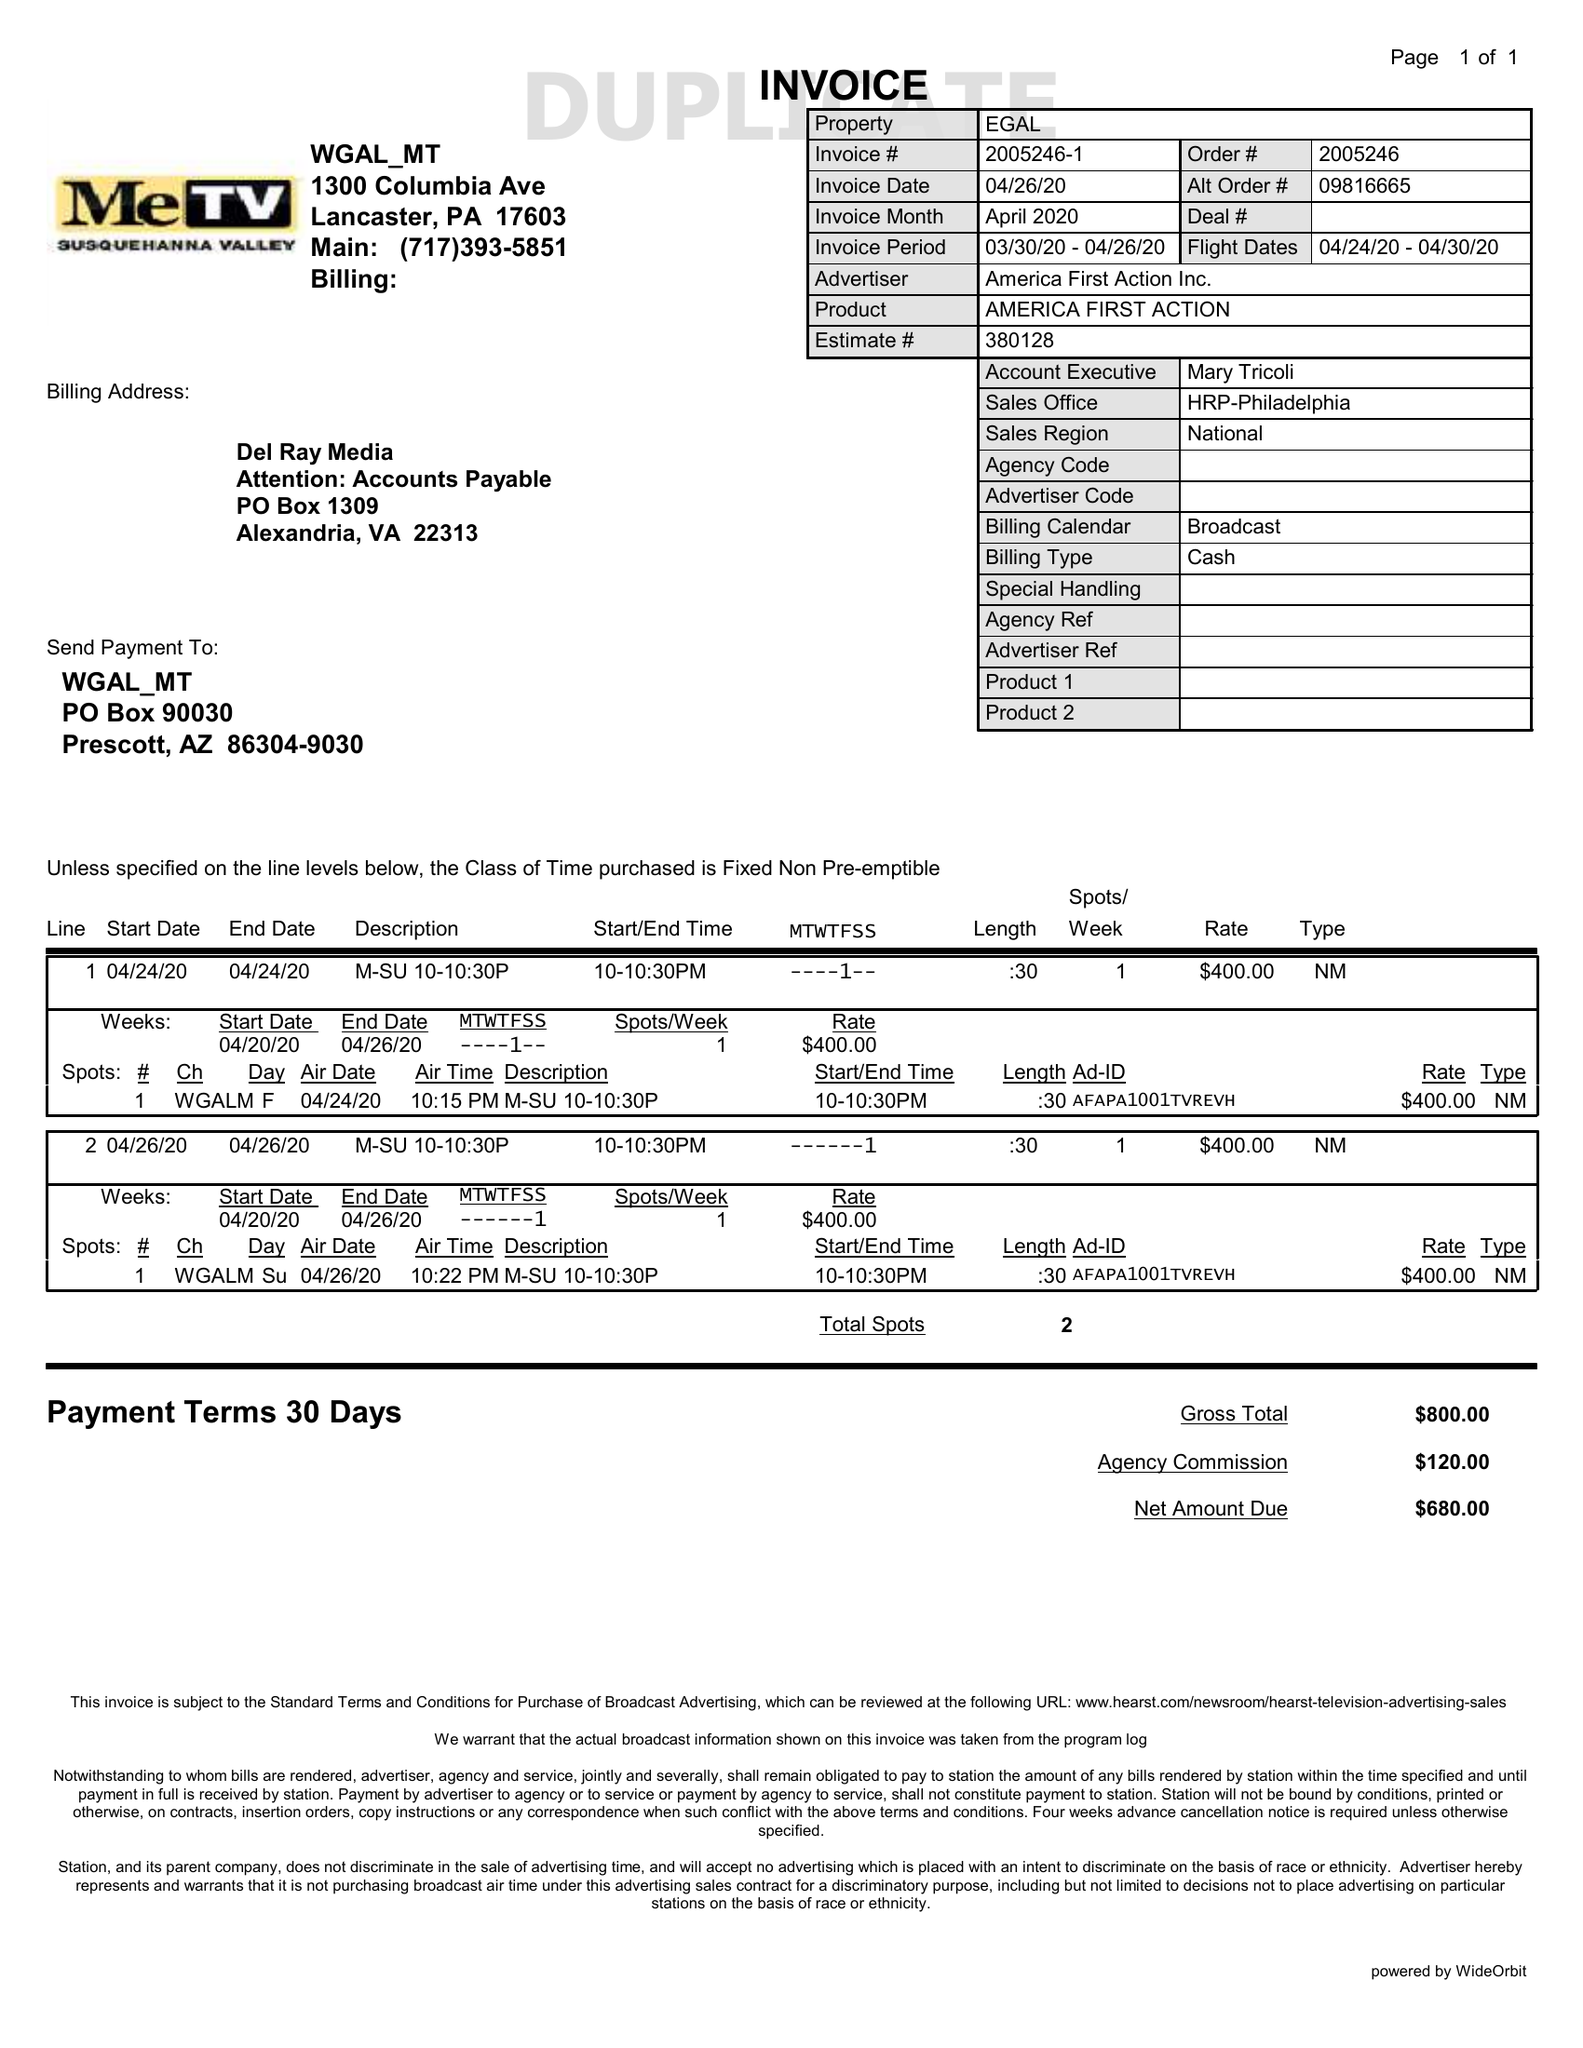What is the value for the flight_from?
Answer the question using a single word or phrase. 04/24/20 